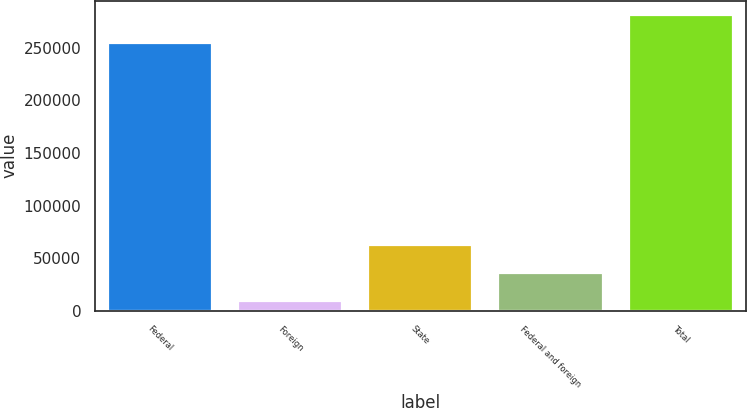<chart> <loc_0><loc_0><loc_500><loc_500><bar_chart><fcel>Federal<fcel>Foreign<fcel>State<fcel>Federal and foreign<fcel>Total<nl><fcel>254021<fcel>9084<fcel>62190.4<fcel>35637.2<fcel>280574<nl></chart> 